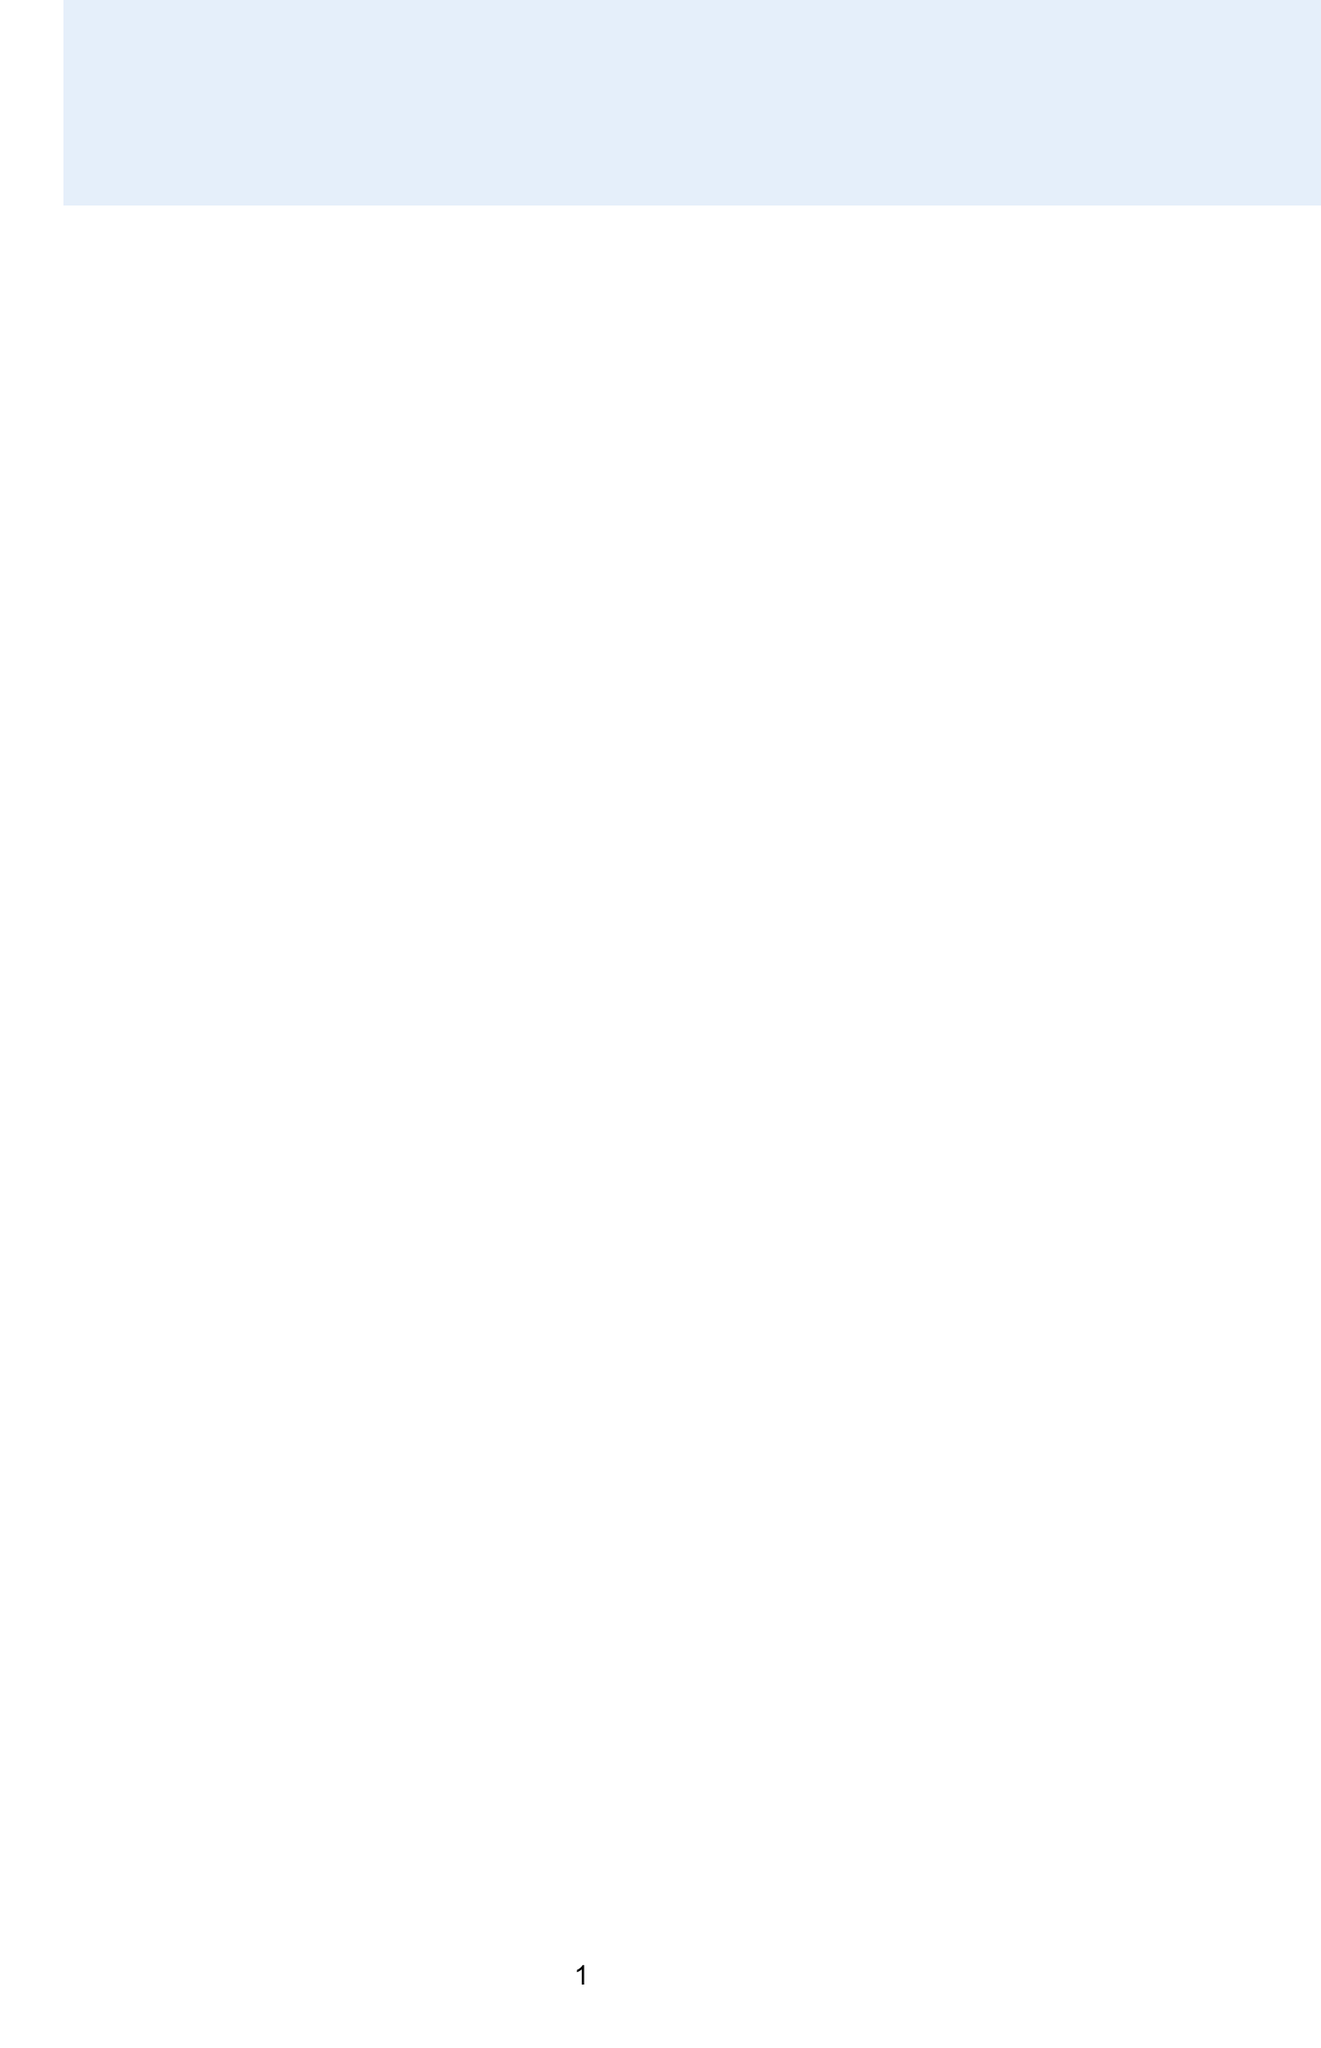What is the main focus of this comparative study? The study aims to analyze Professor Nadeem's techniques against other leading methodologies, focusing on energy efficiency, network throughput, interference management, and Quality of Service.
Answer: Energy efficiency, network throughput, interference management, Quality of Service What is the energy efficiency method proposed by Professor Nadeem? The energy efficiency method proposed by Professor Nadeem is the Adaptive Power Control Algorithm (APCA).
Answer: Adaptive Power Control Algorithm (APCA) How much does APCA reduce power consumption? APCA offers significant reductions in power consumption, stated as a percentage.
Answer: Up to 30% Who developed the Sleep-Wake Scheduling Protocol? The Sleep-Wake Scheduling Protocol was developed by Dr. Jennifer Chen at Stanford University.
Answer: Dr. Jennifer Chen, Stanford University What improvement in network capacity was achieved in the 5G network deployment case study? The case study reports a specific percentage improvement in network capacity resulting from Professor Nadeem's technique.
Answer: 30% Which method demonstrates better scalability compared to DAS? The document mentions a specific method that shows better scalability and adaptability.
Answer: Cognitive Interference Alignment (CIA) What is one future direction mentioned for Professor Nadeem's techniques? The document lists several future directions, one of which involves the application of technology for optimization.
Answer: Integration with artificial intelligence for adaptive optimization What was the outcome of the IoT Network for Smart Agriculture study? The outcome reflects improvements in two key areas of the network after implementing the techniques described.
Answer: 50% increase in network lifetime and 35% improvement in data reliability 